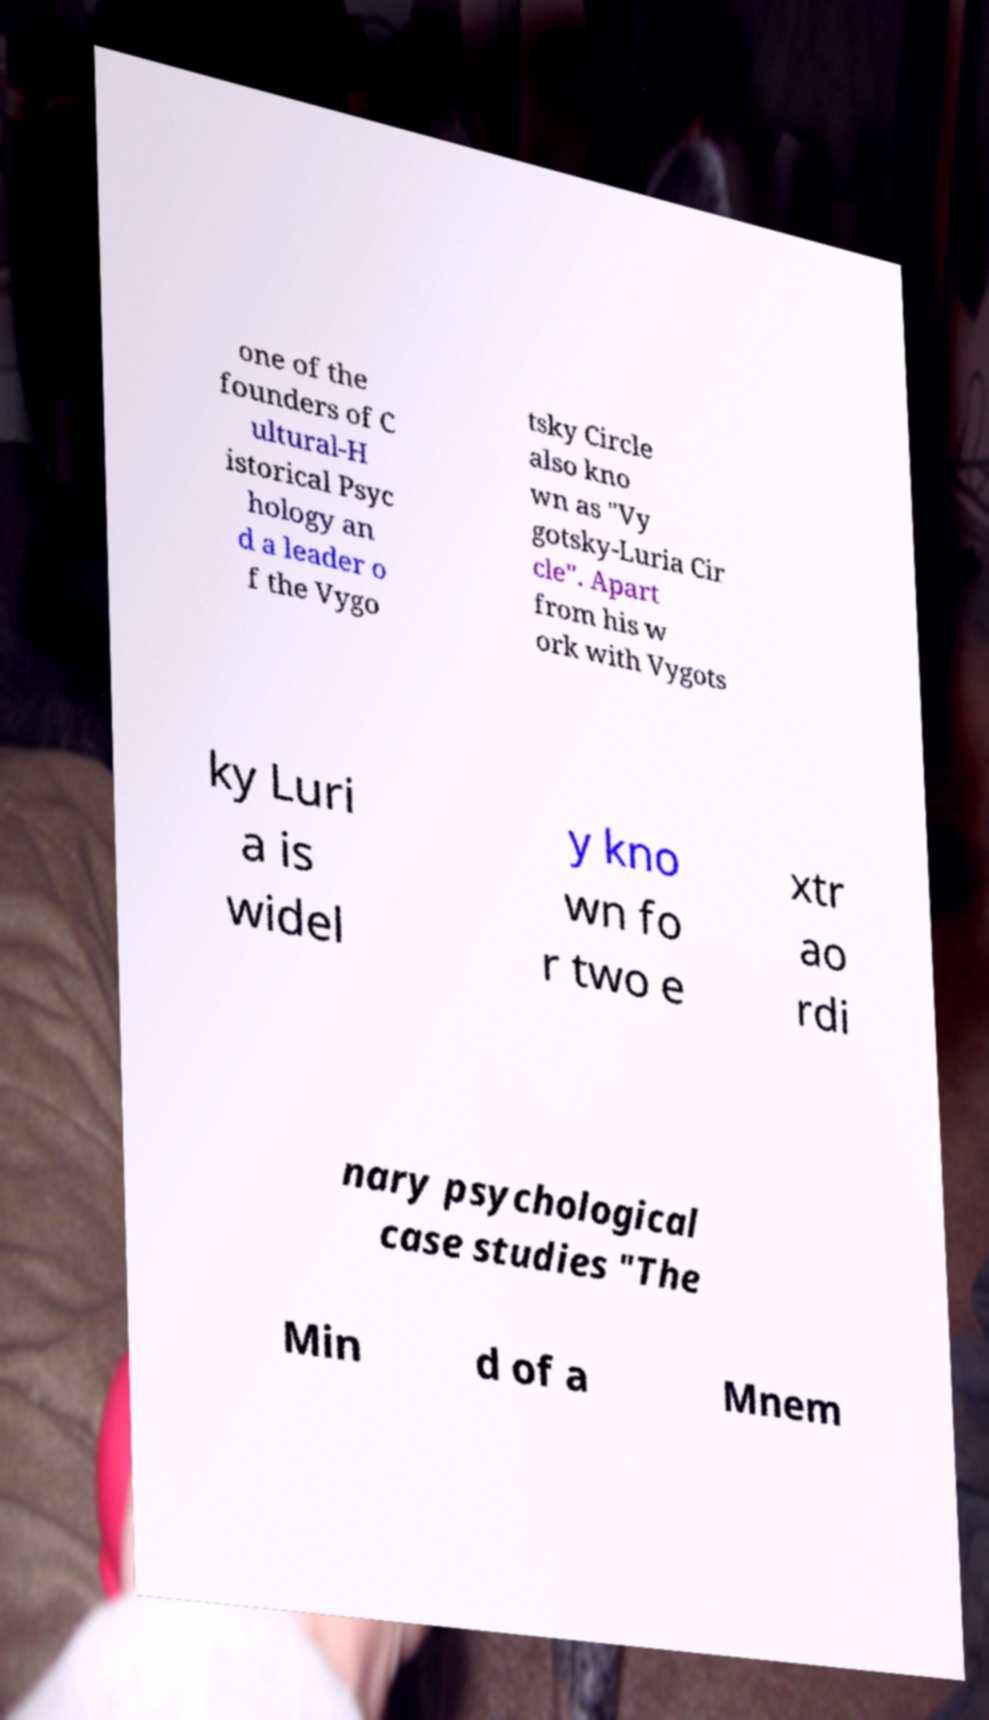Could you assist in decoding the text presented in this image and type it out clearly? one of the founders of C ultural-H istorical Psyc hology an d a leader o f the Vygo tsky Circle also kno wn as "Vy gotsky-Luria Cir cle". Apart from his w ork with Vygots ky Luri a is widel y kno wn fo r two e xtr ao rdi nary psychological case studies "The Min d of a Mnem 